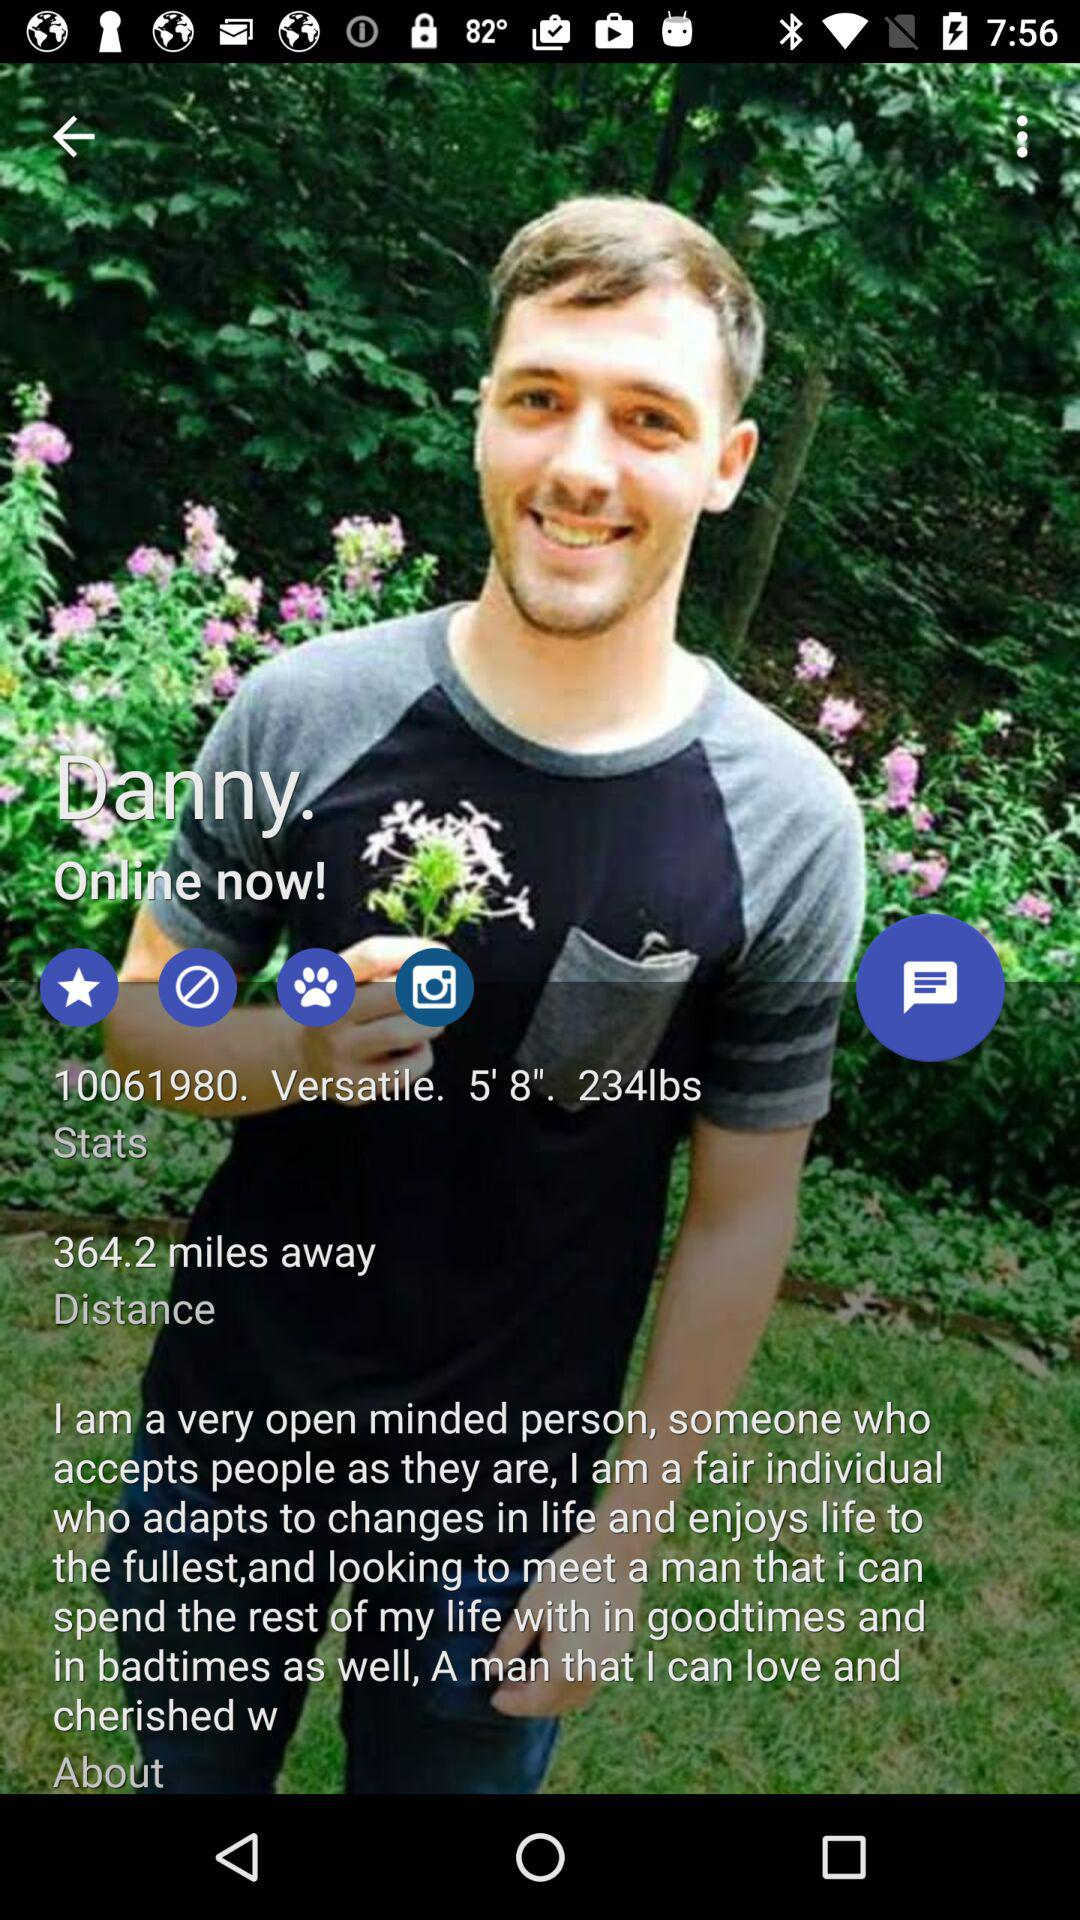How far away does Danny live? Danny lives 364.2 miles away. 